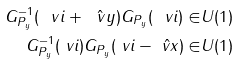<formula> <loc_0><loc_0><loc_500><loc_500>G _ { P _ { y } } ^ { - 1 } ( \ v i + \hat { \ v y } ) G _ { P _ { y } } ( \ v i ) \in & U ( 1 ) \\ G _ { P _ { y } } ^ { - 1 } ( \ v i ) G _ { P _ { y } } ( \ v i - \hat { \ v x } ) \in & U ( 1 )</formula> 